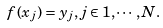<formula> <loc_0><loc_0><loc_500><loc_500>f ( x _ { j } ) = y _ { j } , j \in 1 , \cdots , N .</formula> 